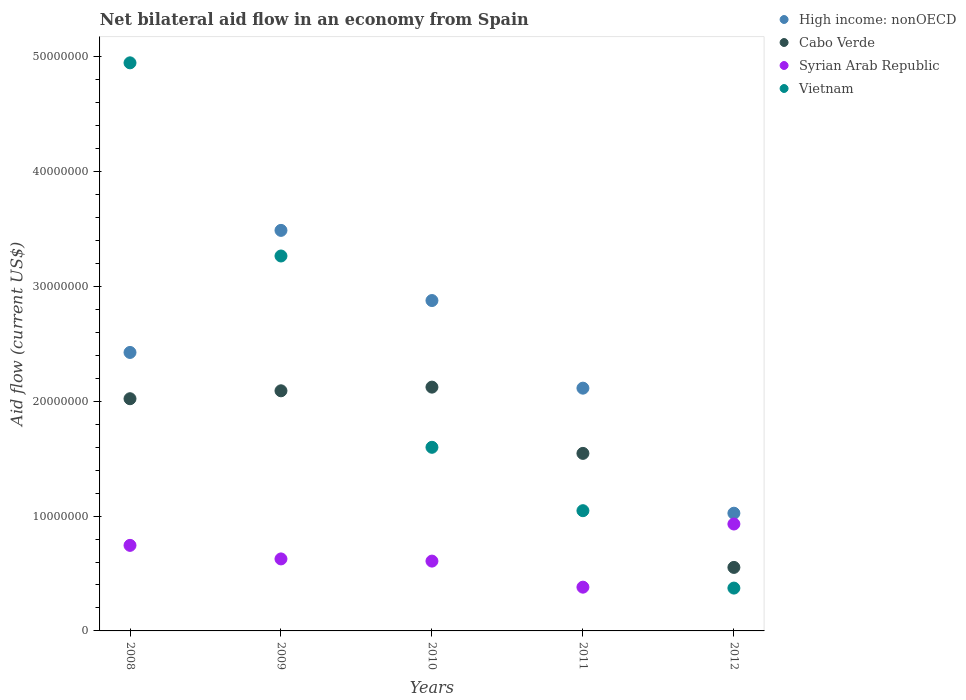How many different coloured dotlines are there?
Provide a short and direct response. 4. Is the number of dotlines equal to the number of legend labels?
Keep it short and to the point. Yes. What is the net bilateral aid flow in Vietnam in 2009?
Your response must be concise. 3.26e+07. Across all years, what is the maximum net bilateral aid flow in Cabo Verde?
Offer a very short reply. 2.12e+07. Across all years, what is the minimum net bilateral aid flow in Vietnam?
Your answer should be very brief. 3.73e+06. In which year was the net bilateral aid flow in Vietnam minimum?
Provide a succinct answer. 2012. What is the total net bilateral aid flow in Cabo Verde in the graph?
Keep it short and to the point. 8.34e+07. What is the difference between the net bilateral aid flow in Syrian Arab Republic in 2008 and that in 2009?
Ensure brevity in your answer.  1.18e+06. What is the difference between the net bilateral aid flow in High income: nonOECD in 2011 and the net bilateral aid flow in Cabo Verde in 2008?
Offer a terse response. 9.20e+05. What is the average net bilateral aid flow in Syrian Arab Republic per year?
Provide a succinct answer. 6.58e+06. In the year 2010, what is the difference between the net bilateral aid flow in High income: nonOECD and net bilateral aid flow in Cabo Verde?
Your answer should be very brief. 7.54e+06. What is the ratio of the net bilateral aid flow in Cabo Verde in 2008 to that in 2012?
Your response must be concise. 3.66. Is the difference between the net bilateral aid flow in High income: nonOECD in 2010 and 2012 greater than the difference between the net bilateral aid flow in Cabo Verde in 2010 and 2012?
Keep it short and to the point. Yes. What is the difference between the highest and the second highest net bilateral aid flow in Vietnam?
Make the answer very short. 1.68e+07. What is the difference between the highest and the lowest net bilateral aid flow in High income: nonOECD?
Ensure brevity in your answer.  2.46e+07. In how many years, is the net bilateral aid flow in Cabo Verde greater than the average net bilateral aid flow in Cabo Verde taken over all years?
Offer a terse response. 3. Is the sum of the net bilateral aid flow in Syrian Arab Republic in 2009 and 2011 greater than the maximum net bilateral aid flow in Cabo Verde across all years?
Offer a terse response. No. Is it the case that in every year, the sum of the net bilateral aid flow in Syrian Arab Republic and net bilateral aid flow in High income: nonOECD  is greater than the sum of net bilateral aid flow in Vietnam and net bilateral aid flow in Cabo Verde?
Ensure brevity in your answer.  No. Is it the case that in every year, the sum of the net bilateral aid flow in Vietnam and net bilateral aid flow in Syrian Arab Republic  is greater than the net bilateral aid flow in High income: nonOECD?
Give a very brief answer. No. Is the net bilateral aid flow in Vietnam strictly greater than the net bilateral aid flow in Syrian Arab Republic over the years?
Keep it short and to the point. No. Is the net bilateral aid flow in Vietnam strictly less than the net bilateral aid flow in Syrian Arab Republic over the years?
Ensure brevity in your answer.  No. How many years are there in the graph?
Ensure brevity in your answer.  5. Are the values on the major ticks of Y-axis written in scientific E-notation?
Offer a terse response. No. How are the legend labels stacked?
Make the answer very short. Vertical. What is the title of the graph?
Offer a terse response. Net bilateral aid flow in an economy from Spain. Does "Libya" appear as one of the legend labels in the graph?
Offer a terse response. No. What is the Aid flow (current US$) in High income: nonOECD in 2008?
Your response must be concise. 2.42e+07. What is the Aid flow (current US$) in Cabo Verde in 2008?
Keep it short and to the point. 2.02e+07. What is the Aid flow (current US$) of Syrian Arab Republic in 2008?
Make the answer very short. 7.45e+06. What is the Aid flow (current US$) of Vietnam in 2008?
Offer a very short reply. 4.95e+07. What is the Aid flow (current US$) in High income: nonOECD in 2009?
Ensure brevity in your answer.  3.49e+07. What is the Aid flow (current US$) in Cabo Verde in 2009?
Provide a succinct answer. 2.09e+07. What is the Aid flow (current US$) in Syrian Arab Republic in 2009?
Provide a short and direct response. 6.27e+06. What is the Aid flow (current US$) in Vietnam in 2009?
Offer a very short reply. 3.26e+07. What is the Aid flow (current US$) in High income: nonOECD in 2010?
Your answer should be compact. 2.88e+07. What is the Aid flow (current US$) of Cabo Verde in 2010?
Provide a short and direct response. 2.12e+07. What is the Aid flow (current US$) in Syrian Arab Republic in 2010?
Offer a terse response. 6.08e+06. What is the Aid flow (current US$) in Vietnam in 2010?
Offer a terse response. 1.60e+07. What is the Aid flow (current US$) in High income: nonOECD in 2011?
Provide a succinct answer. 2.11e+07. What is the Aid flow (current US$) in Cabo Verde in 2011?
Your answer should be very brief. 1.55e+07. What is the Aid flow (current US$) of Syrian Arab Republic in 2011?
Your response must be concise. 3.81e+06. What is the Aid flow (current US$) of Vietnam in 2011?
Your answer should be compact. 1.05e+07. What is the Aid flow (current US$) of High income: nonOECD in 2012?
Make the answer very short. 1.02e+07. What is the Aid flow (current US$) in Cabo Verde in 2012?
Make the answer very short. 5.53e+06. What is the Aid flow (current US$) in Syrian Arab Republic in 2012?
Your answer should be very brief. 9.31e+06. What is the Aid flow (current US$) in Vietnam in 2012?
Offer a very short reply. 3.73e+06. Across all years, what is the maximum Aid flow (current US$) in High income: nonOECD?
Keep it short and to the point. 3.49e+07. Across all years, what is the maximum Aid flow (current US$) in Cabo Verde?
Make the answer very short. 2.12e+07. Across all years, what is the maximum Aid flow (current US$) of Syrian Arab Republic?
Your answer should be compact. 9.31e+06. Across all years, what is the maximum Aid flow (current US$) in Vietnam?
Keep it short and to the point. 4.95e+07. Across all years, what is the minimum Aid flow (current US$) in High income: nonOECD?
Ensure brevity in your answer.  1.02e+07. Across all years, what is the minimum Aid flow (current US$) of Cabo Verde?
Provide a short and direct response. 5.53e+06. Across all years, what is the minimum Aid flow (current US$) of Syrian Arab Republic?
Keep it short and to the point. 3.81e+06. Across all years, what is the minimum Aid flow (current US$) of Vietnam?
Provide a short and direct response. 3.73e+06. What is the total Aid flow (current US$) in High income: nonOECD in the graph?
Your answer should be very brief. 1.19e+08. What is the total Aid flow (current US$) of Cabo Verde in the graph?
Provide a succinct answer. 8.34e+07. What is the total Aid flow (current US$) of Syrian Arab Republic in the graph?
Provide a succinct answer. 3.29e+07. What is the total Aid flow (current US$) of Vietnam in the graph?
Your response must be concise. 1.12e+08. What is the difference between the Aid flow (current US$) of High income: nonOECD in 2008 and that in 2009?
Your answer should be compact. -1.06e+07. What is the difference between the Aid flow (current US$) of Cabo Verde in 2008 and that in 2009?
Offer a very short reply. -6.90e+05. What is the difference between the Aid flow (current US$) in Syrian Arab Republic in 2008 and that in 2009?
Offer a very short reply. 1.18e+06. What is the difference between the Aid flow (current US$) of Vietnam in 2008 and that in 2009?
Your answer should be compact. 1.68e+07. What is the difference between the Aid flow (current US$) of High income: nonOECD in 2008 and that in 2010?
Keep it short and to the point. -4.52e+06. What is the difference between the Aid flow (current US$) of Cabo Verde in 2008 and that in 2010?
Keep it short and to the point. -1.01e+06. What is the difference between the Aid flow (current US$) in Syrian Arab Republic in 2008 and that in 2010?
Keep it short and to the point. 1.37e+06. What is the difference between the Aid flow (current US$) in Vietnam in 2008 and that in 2010?
Offer a very short reply. 3.35e+07. What is the difference between the Aid flow (current US$) in High income: nonOECD in 2008 and that in 2011?
Your answer should be very brief. 3.11e+06. What is the difference between the Aid flow (current US$) of Cabo Verde in 2008 and that in 2011?
Your answer should be very brief. 4.76e+06. What is the difference between the Aid flow (current US$) in Syrian Arab Republic in 2008 and that in 2011?
Your answer should be very brief. 3.64e+06. What is the difference between the Aid flow (current US$) in Vietnam in 2008 and that in 2011?
Give a very brief answer. 3.90e+07. What is the difference between the Aid flow (current US$) of High income: nonOECD in 2008 and that in 2012?
Provide a short and direct response. 1.40e+07. What is the difference between the Aid flow (current US$) of Cabo Verde in 2008 and that in 2012?
Give a very brief answer. 1.47e+07. What is the difference between the Aid flow (current US$) in Syrian Arab Republic in 2008 and that in 2012?
Provide a succinct answer. -1.86e+06. What is the difference between the Aid flow (current US$) in Vietnam in 2008 and that in 2012?
Your answer should be compact. 4.57e+07. What is the difference between the Aid flow (current US$) of High income: nonOECD in 2009 and that in 2010?
Make the answer very short. 6.11e+06. What is the difference between the Aid flow (current US$) of Cabo Verde in 2009 and that in 2010?
Your answer should be very brief. -3.20e+05. What is the difference between the Aid flow (current US$) in Syrian Arab Republic in 2009 and that in 2010?
Your answer should be very brief. 1.90e+05. What is the difference between the Aid flow (current US$) of Vietnam in 2009 and that in 2010?
Make the answer very short. 1.67e+07. What is the difference between the Aid flow (current US$) in High income: nonOECD in 2009 and that in 2011?
Make the answer very short. 1.37e+07. What is the difference between the Aid flow (current US$) of Cabo Verde in 2009 and that in 2011?
Your answer should be compact. 5.45e+06. What is the difference between the Aid flow (current US$) of Syrian Arab Republic in 2009 and that in 2011?
Your answer should be compact. 2.46e+06. What is the difference between the Aid flow (current US$) in Vietnam in 2009 and that in 2011?
Provide a short and direct response. 2.22e+07. What is the difference between the Aid flow (current US$) of High income: nonOECD in 2009 and that in 2012?
Offer a very short reply. 2.46e+07. What is the difference between the Aid flow (current US$) of Cabo Verde in 2009 and that in 2012?
Offer a very short reply. 1.54e+07. What is the difference between the Aid flow (current US$) of Syrian Arab Republic in 2009 and that in 2012?
Offer a terse response. -3.04e+06. What is the difference between the Aid flow (current US$) of Vietnam in 2009 and that in 2012?
Offer a terse response. 2.89e+07. What is the difference between the Aid flow (current US$) in High income: nonOECD in 2010 and that in 2011?
Make the answer very short. 7.63e+06. What is the difference between the Aid flow (current US$) in Cabo Verde in 2010 and that in 2011?
Provide a succinct answer. 5.77e+06. What is the difference between the Aid flow (current US$) in Syrian Arab Republic in 2010 and that in 2011?
Provide a short and direct response. 2.27e+06. What is the difference between the Aid flow (current US$) in Vietnam in 2010 and that in 2011?
Make the answer very short. 5.52e+06. What is the difference between the Aid flow (current US$) in High income: nonOECD in 2010 and that in 2012?
Your answer should be compact. 1.85e+07. What is the difference between the Aid flow (current US$) in Cabo Verde in 2010 and that in 2012?
Your answer should be very brief. 1.57e+07. What is the difference between the Aid flow (current US$) in Syrian Arab Republic in 2010 and that in 2012?
Ensure brevity in your answer.  -3.23e+06. What is the difference between the Aid flow (current US$) in Vietnam in 2010 and that in 2012?
Offer a very short reply. 1.23e+07. What is the difference between the Aid flow (current US$) of High income: nonOECD in 2011 and that in 2012?
Provide a succinct answer. 1.09e+07. What is the difference between the Aid flow (current US$) of Cabo Verde in 2011 and that in 2012?
Ensure brevity in your answer.  9.93e+06. What is the difference between the Aid flow (current US$) of Syrian Arab Republic in 2011 and that in 2012?
Your answer should be compact. -5.50e+06. What is the difference between the Aid flow (current US$) of Vietnam in 2011 and that in 2012?
Keep it short and to the point. 6.74e+06. What is the difference between the Aid flow (current US$) in High income: nonOECD in 2008 and the Aid flow (current US$) in Cabo Verde in 2009?
Offer a terse response. 3.34e+06. What is the difference between the Aid flow (current US$) in High income: nonOECD in 2008 and the Aid flow (current US$) in Syrian Arab Republic in 2009?
Your response must be concise. 1.80e+07. What is the difference between the Aid flow (current US$) in High income: nonOECD in 2008 and the Aid flow (current US$) in Vietnam in 2009?
Provide a short and direct response. -8.40e+06. What is the difference between the Aid flow (current US$) in Cabo Verde in 2008 and the Aid flow (current US$) in Syrian Arab Republic in 2009?
Keep it short and to the point. 1.40e+07. What is the difference between the Aid flow (current US$) of Cabo Verde in 2008 and the Aid flow (current US$) of Vietnam in 2009?
Ensure brevity in your answer.  -1.24e+07. What is the difference between the Aid flow (current US$) of Syrian Arab Republic in 2008 and the Aid flow (current US$) of Vietnam in 2009?
Offer a terse response. -2.52e+07. What is the difference between the Aid flow (current US$) of High income: nonOECD in 2008 and the Aid flow (current US$) of Cabo Verde in 2010?
Provide a short and direct response. 3.02e+06. What is the difference between the Aid flow (current US$) in High income: nonOECD in 2008 and the Aid flow (current US$) in Syrian Arab Republic in 2010?
Give a very brief answer. 1.82e+07. What is the difference between the Aid flow (current US$) in High income: nonOECD in 2008 and the Aid flow (current US$) in Vietnam in 2010?
Give a very brief answer. 8.26e+06. What is the difference between the Aid flow (current US$) in Cabo Verde in 2008 and the Aid flow (current US$) in Syrian Arab Republic in 2010?
Give a very brief answer. 1.41e+07. What is the difference between the Aid flow (current US$) in Cabo Verde in 2008 and the Aid flow (current US$) in Vietnam in 2010?
Give a very brief answer. 4.23e+06. What is the difference between the Aid flow (current US$) of Syrian Arab Republic in 2008 and the Aid flow (current US$) of Vietnam in 2010?
Give a very brief answer. -8.54e+06. What is the difference between the Aid flow (current US$) in High income: nonOECD in 2008 and the Aid flow (current US$) in Cabo Verde in 2011?
Your answer should be compact. 8.79e+06. What is the difference between the Aid flow (current US$) in High income: nonOECD in 2008 and the Aid flow (current US$) in Syrian Arab Republic in 2011?
Your answer should be very brief. 2.04e+07. What is the difference between the Aid flow (current US$) in High income: nonOECD in 2008 and the Aid flow (current US$) in Vietnam in 2011?
Provide a succinct answer. 1.38e+07. What is the difference between the Aid flow (current US$) of Cabo Verde in 2008 and the Aid flow (current US$) of Syrian Arab Republic in 2011?
Make the answer very short. 1.64e+07. What is the difference between the Aid flow (current US$) in Cabo Verde in 2008 and the Aid flow (current US$) in Vietnam in 2011?
Give a very brief answer. 9.75e+06. What is the difference between the Aid flow (current US$) of Syrian Arab Republic in 2008 and the Aid flow (current US$) of Vietnam in 2011?
Provide a short and direct response. -3.02e+06. What is the difference between the Aid flow (current US$) in High income: nonOECD in 2008 and the Aid flow (current US$) in Cabo Verde in 2012?
Provide a short and direct response. 1.87e+07. What is the difference between the Aid flow (current US$) of High income: nonOECD in 2008 and the Aid flow (current US$) of Syrian Arab Republic in 2012?
Provide a short and direct response. 1.49e+07. What is the difference between the Aid flow (current US$) in High income: nonOECD in 2008 and the Aid flow (current US$) in Vietnam in 2012?
Your response must be concise. 2.05e+07. What is the difference between the Aid flow (current US$) in Cabo Verde in 2008 and the Aid flow (current US$) in Syrian Arab Republic in 2012?
Make the answer very short. 1.09e+07. What is the difference between the Aid flow (current US$) of Cabo Verde in 2008 and the Aid flow (current US$) of Vietnam in 2012?
Your answer should be very brief. 1.65e+07. What is the difference between the Aid flow (current US$) in Syrian Arab Republic in 2008 and the Aid flow (current US$) in Vietnam in 2012?
Ensure brevity in your answer.  3.72e+06. What is the difference between the Aid flow (current US$) in High income: nonOECD in 2009 and the Aid flow (current US$) in Cabo Verde in 2010?
Ensure brevity in your answer.  1.36e+07. What is the difference between the Aid flow (current US$) in High income: nonOECD in 2009 and the Aid flow (current US$) in Syrian Arab Republic in 2010?
Give a very brief answer. 2.88e+07. What is the difference between the Aid flow (current US$) of High income: nonOECD in 2009 and the Aid flow (current US$) of Vietnam in 2010?
Ensure brevity in your answer.  1.89e+07. What is the difference between the Aid flow (current US$) of Cabo Verde in 2009 and the Aid flow (current US$) of Syrian Arab Republic in 2010?
Ensure brevity in your answer.  1.48e+07. What is the difference between the Aid flow (current US$) in Cabo Verde in 2009 and the Aid flow (current US$) in Vietnam in 2010?
Offer a very short reply. 4.92e+06. What is the difference between the Aid flow (current US$) of Syrian Arab Republic in 2009 and the Aid flow (current US$) of Vietnam in 2010?
Give a very brief answer. -9.72e+06. What is the difference between the Aid flow (current US$) of High income: nonOECD in 2009 and the Aid flow (current US$) of Cabo Verde in 2011?
Give a very brief answer. 1.94e+07. What is the difference between the Aid flow (current US$) of High income: nonOECD in 2009 and the Aid flow (current US$) of Syrian Arab Republic in 2011?
Offer a terse response. 3.11e+07. What is the difference between the Aid flow (current US$) in High income: nonOECD in 2009 and the Aid flow (current US$) in Vietnam in 2011?
Offer a very short reply. 2.44e+07. What is the difference between the Aid flow (current US$) of Cabo Verde in 2009 and the Aid flow (current US$) of Syrian Arab Republic in 2011?
Your answer should be compact. 1.71e+07. What is the difference between the Aid flow (current US$) of Cabo Verde in 2009 and the Aid flow (current US$) of Vietnam in 2011?
Give a very brief answer. 1.04e+07. What is the difference between the Aid flow (current US$) of Syrian Arab Republic in 2009 and the Aid flow (current US$) of Vietnam in 2011?
Your answer should be compact. -4.20e+06. What is the difference between the Aid flow (current US$) in High income: nonOECD in 2009 and the Aid flow (current US$) in Cabo Verde in 2012?
Ensure brevity in your answer.  2.94e+07. What is the difference between the Aid flow (current US$) of High income: nonOECD in 2009 and the Aid flow (current US$) of Syrian Arab Republic in 2012?
Ensure brevity in your answer.  2.56e+07. What is the difference between the Aid flow (current US$) in High income: nonOECD in 2009 and the Aid flow (current US$) in Vietnam in 2012?
Ensure brevity in your answer.  3.12e+07. What is the difference between the Aid flow (current US$) in Cabo Verde in 2009 and the Aid flow (current US$) in Syrian Arab Republic in 2012?
Keep it short and to the point. 1.16e+07. What is the difference between the Aid flow (current US$) in Cabo Verde in 2009 and the Aid flow (current US$) in Vietnam in 2012?
Provide a short and direct response. 1.72e+07. What is the difference between the Aid flow (current US$) of Syrian Arab Republic in 2009 and the Aid flow (current US$) of Vietnam in 2012?
Your answer should be very brief. 2.54e+06. What is the difference between the Aid flow (current US$) in High income: nonOECD in 2010 and the Aid flow (current US$) in Cabo Verde in 2011?
Offer a terse response. 1.33e+07. What is the difference between the Aid flow (current US$) of High income: nonOECD in 2010 and the Aid flow (current US$) of Syrian Arab Republic in 2011?
Ensure brevity in your answer.  2.50e+07. What is the difference between the Aid flow (current US$) of High income: nonOECD in 2010 and the Aid flow (current US$) of Vietnam in 2011?
Your answer should be compact. 1.83e+07. What is the difference between the Aid flow (current US$) of Cabo Verde in 2010 and the Aid flow (current US$) of Syrian Arab Republic in 2011?
Your answer should be very brief. 1.74e+07. What is the difference between the Aid flow (current US$) in Cabo Verde in 2010 and the Aid flow (current US$) in Vietnam in 2011?
Offer a terse response. 1.08e+07. What is the difference between the Aid flow (current US$) of Syrian Arab Republic in 2010 and the Aid flow (current US$) of Vietnam in 2011?
Provide a succinct answer. -4.39e+06. What is the difference between the Aid flow (current US$) in High income: nonOECD in 2010 and the Aid flow (current US$) in Cabo Verde in 2012?
Your answer should be compact. 2.32e+07. What is the difference between the Aid flow (current US$) in High income: nonOECD in 2010 and the Aid flow (current US$) in Syrian Arab Republic in 2012?
Keep it short and to the point. 1.95e+07. What is the difference between the Aid flow (current US$) in High income: nonOECD in 2010 and the Aid flow (current US$) in Vietnam in 2012?
Keep it short and to the point. 2.50e+07. What is the difference between the Aid flow (current US$) of Cabo Verde in 2010 and the Aid flow (current US$) of Syrian Arab Republic in 2012?
Your answer should be compact. 1.19e+07. What is the difference between the Aid flow (current US$) of Cabo Verde in 2010 and the Aid flow (current US$) of Vietnam in 2012?
Offer a terse response. 1.75e+07. What is the difference between the Aid flow (current US$) in Syrian Arab Republic in 2010 and the Aid flow (current US$) in Vietnam in 2012?
Your response must be concise. 2.35e+06. What is the difference between the Aid flow (current US$) in High income: nonOECD in 2011 and the Aid flow (current US$) in Cabo Verde in 2012?
Your response must be concise. 1.56e+07. What is the difference between the Aid flow (current US$) in High income: nonOECD in 2011 and the Aid flow (current US$) in Syrian Arab Republic in 2012?
Your response must be concise. 1.18e+07. What is the difference between the Aid flow (current US$) of High income: nonOECD in 2011 and the Aid flow (current US$) of Vietnam in 2012?
Your answer should be very brief. 1.74e+07. What is the difference between the Aid flow (current US$) of Cabo Verde in 2011 and the Aid flow (current US$) of Syrian Arab Republic in 2012?
Ensure brevity in your answer.  6.15e+06. What is the difference between the Aid flow (current US$) in Cabo Verde in 2011 and the Aid flow (current US$) in Vietnam in 2012?
Offer a terse response. 1.17e+07. What is the average Aid flow (current US$) in High income: nonOECD per year?
Provide a short and direct response. 2.39e+07. What is the average Aid flow (current US$) in Cabo Verde per year?
Your response must be concise. 1.67e+07. What is the average Aid flow (current US$) of Syrian Arab Republic per year?
Make the answer very short. 6.58e+06. What is the average Aid flow (current US$) in Vietnam per year?
Give a very brief answer. 2.25e+07. In the year 2008, what is the difference between the Aid flow (current US$) in High income: nonOECD and Aid flow (current US$) in Cabo Verde?
Provide a short and direct response. 4.03e+06. In the year 2008, what is the difference between the Aid flow (current US$) of High income: nonOECD and Aid flow (current US$) of Syrian Arab Republic?
Make the answer very short. 1.68e+07. In the year 2008, what is the difference between the Aid flow (current US$) in High income: nonOECD and Aid flow (current US$) in Vietnam?
Ensure brevity in your answer.  -2.52e+07. In the year 2008, what is the difference between the Aid flow (current US$) in Cabo Verde and Aid flow (current US$) in Syrian Arab Republic?
Make the answer very short. 1.28e+07. In the year 2008, what is the difference between the Aid flow (current US$) in Cabo Verde and Aid flow (current US$) in Vietnam?
Make the answer very short. -2.92e+07. In the year 2008, what is the difference between the Aid flow (current US$) in Syrian Arab Republic and Aid flow (current US$) in Vietnam?
Make the answer very short. -4.20e+07. In the year 2009, what is the difference between the Aid flow (current US$) of High income: nonOECD and Aid flow (current US$) of Cabo Verde?
Offer a very short reply. 1.40e+07. In the year 2009, what is the difference between the Aid flow (current US$) in High income: nonOECD and Aid flow (current US$) in Syrian Arab Republic?
Your response must be concise. 2.86e+07. In the year 2009, what is the difference between the Aid flow (current US$) of High income: nonOECD and Aid flow (current US$) of Vietnam?
Offer a terse response. 2.23e+06. In the year 2009, what is the difference between the Aid flow (current US$) in Cabo Verde and Aid flow (current US$) in Syrian Arab Republic?
Keep it short and to the point. 1.46e+07. In the year 2009, what is the difference between the Aid flow (current US$) of Cabo Verde and Aid flow (current US$) of Vietnam?
Keep it short and to the point. -1.17e+07. In the year 2009, what is the difference between the Aid flow (current US$) of Syrian Arab Republic and Aid flow (current US$) of Vietnam?
Provide a short and direct response. -2.64e+07. In the year 2010, what is the difference between the Aid flow (current US$) in High income: nonOECD and Aid flow (current US$) in Cabo Verde?
Provide a short and direct response. 7.54e+06. In the year 2010, what is the difference between the Aid flow (current US$) of High income: nonOECD and Aid flow (current US$) of Syrian Arab Republic?
Make the answer very short. 2.27e+07. In the year 2010, what is the difference between the Aid flow (current US$) of High income: nonOECD and Aid flow (current US$) of Vietnam?
Offer a very short reply. 1.28e+07. In the year 2010, what is the difference between the Aid flow (current US$) in Cabo Verde and Aid flow (current US$) in Syrian Arab Republic?
Provide a short and direct response. 1.52e+07. In the year 2010, what is the difference between the Aid flow (current US$) of Cabo Verde and Aid flow (current US$) of Vietnam?
Provide a short and direct response. 5.24e+06. In the year 2010, what is the difference between the Aid flow (current US$) in Syrian Arab Republic and Aid flow (current US$) in Vietnam?
Keep it short and to the point. -9.91e+06. In the year 2011, what is the difference between the Aid flow (current US$) of High income: nonOECD and Aid flow (current US$) of Cabo Verde?
Offer a terse response. 5.68e+06. In the year 2011, what is the difference between the Aid flow (current US$) in High income: nonOECD and Aid flow (current US$) in Syrian Arab Republic?
Make the answer very short. 1.73e+07. In the year 2011, what is the difference between the Aid flow (current US$) in High income: nonOECD and Aid flow (current US$) in Vietnam?
Keep it short and to the point. 1.07e+07. In the year 2011, what is the difference between the Aid flow (current US$) of Cabo Verde and Aid flow (current US$) of Syrian Arab Republic?
Keep it short and to the point. 1.16e+07. In the year 2011, what is the difference between the Aid flow (current US$) of Cabo Verde and Aid flow (current US$) of Vietnam?
Your answer should be compact. 4.99e+06. In the year 2011, what is the difference between the Aid flow (current US$) in Syrian Arab Republic and Aid flow (current US$) in Vietnam?
Make the answer very short. -6.66e+06. In the year 2012, what is the difference between the Aid flow (current US$) in High income: nonOECD and Aid flow (current US$) in Cabo Verde?
Make the answer very short. 4.72e+06. In the year 2012, what is the difference between the Aid flow (current US$) in High income: nonOECD and Aid flow (current US$) in Syrian Arab Republic?
Offer a very short reply. 9.40e+05. In the year 2012, what is the difference between the Aid flow (current US$) of High income: nonOECD and Aid flow (current US$) of Vietnam?
Provide a succinct answer. 6.52e+06. In the year 2012, what is the difference between the Aid flow (current US$) of Cabo Verde and Aid flow (current US$) of Syrian Arab Republic?
Provide a short and direct response. -3.78e+06. In the year 2012, what is the difference between the Aid flow (current US$) of Cabo Verde and Aid flow (current US$) of Vietnam?
Provide a short and direct response. 1.80e+06. In the year 2012, what is the difference between the Aid flow (current US$) in Syrian Arab Republic and Aid flow (current US$) in Vietnam?
Offer a very short reply. 5.58e+06. What is the ratio of the Aid flow (current US$) of High income: nonOECD in 2008 to that in 2009?
Your answer should be very brief. 0.7. What is the ratio of the Aid flow (current US$) of Cabo Verde in 2008 to that in 2009?
Give a very brief answer. 0.97. What is the ratio of the Aid flow (current US$) of Syrian Arab Republic in 2008 to that in 2009?
Your answer should be compact. 1.19. What is the ratio of the Aid flow (current US$) in Vietnam in 2008 to that in 2009?
Your response must be concise. 1.52. What is the ratio of the Aid flow (current US$) of High income: nonOECD in 2008 to that in 2010?
Make the answer very short. 0.84. What is the ratio of the Aid flow (current US$) of Cabo Verde in 2008 to that in 2010?
Provide a succinct answer. 0.95. What is the ratio of the Aid flow (current US$) in Syrian Arab Republic in 2008 to that in 2010?
Make the answer very short. 1.23. What is the ratio of the Aid flow (current US$) of Vietnam in 2008 to that in 2010?
Your response must be concise. 3.09. What is the ratio of the Aid flow (current US$) in High income: nonOECD in 2008 to that in 2011?
Your answer should be compact. 1.15. What is the ratio of the Aid flow (current US$) in Cabo Verde in 2008 to that in 2011?
Your response must be concise. 1.31. What is the ratio of the Aid flow (current US$) of Syrian Arab Republic in 2008 to that in 2011?
Give a very brief answer. 1.96. What is the ratio of the Aid flow (current US$) of Vietnam in 2008 to that in 2011?
Your answer should be very brief. 4.72. What is the ratio of the Aid flow (current US$) in High income: nonOECD in 2008 to that in 2012?
Keep it short and to the point. 2.37. What is the ratio of the Aid flow (current US$) in Cabo Verde in 2008 to that in 2012?
Keep it short and to the point. 3.66. What is the ratio of the Aid flow (current US$) in Syrian Arab Republic in 2008 to that in 2012?
Offer a very short reply. 0.8. What is the ratio of the Aid flow (current US$) of Vietnam in 2008 to that in 2012?
Your response must be concise. 13.26. What is the ratio of the Aid flow (current US$) of High income: nonOECD in 2009 to that in 2010?
Offer a very short reply. 1.21. What is the ratio of the Aid flow (current US$) of Cabo Verde in 2009 to that in 2010?
Your response must be concise. 0.98. What is the ratio of the Aid flow (current US$) in Syrian Arab Republic in 2009 to that in 2010?
Offer a very short reply. 1.03. What is the ratio of the Aid flow (current US$) of Vietnam in 2009 to that in 2010?
Offer a very short reply. 2.04. What is the ratio of the Aid flow (current US$) of High income: nonOECD in 2009 to that in 2011?
Your answer should be very brief. 1.65. What is the ratio of the Aid flow (current US$) in Cabo Verde in 2009 to that in 2011?
Ensure brevity in your answer.  1.35. What is the ratio of the Aid flow (current US$) in Syrian Arab Republic in 2009 to that in 2011?
Offer a terse response. 1.65. What is the ratio of the Aid flow (current US$) of Vietnam in 2009 to that in 2011?
Provide a succinct answer. 3.12. What is the ratio of the Aid flow (current US$) in High income: nonOECD in 2009 to that in 2012?
Your answer should be very brief. 3.4. What is the ratio of the Aid flow (current US$) of Cabo Verde in 2009 to that in 2012?
Offer a very short reply. 3.78. What is the ratio of the Aid flow (current US$) in Syrian Arab Republic in 2009 to that in 2012?
Your response must be concise. 0.67. What is the ratio of the Aid flow (current US$) of Vietnam in 2009 to that in 2012?
Keep it short and to the point. 8.75. What is the ratio of the Aid flow (current US$) in High income: nonOECD in 2010 to that in 2011?
Make the answer very short. 1.36. What is the ratio of the Aid flow (current US$) in Cabo Verde in 2010 to that in 2011?
Offer a terse response. 1.37. What is the ratio of the Aid flow (current US$) in Syrian Arab Republic in 2010 to that in 2011?
Give a very brief answer. 1.6. What is the ratio of the Aid flow (current US$) in Vietnam in 2010 to that in 2011?
Make the answer very short. 1.53. What is the ratio of the Aid flow (current US$) in High income: nonOECD in 2010 to that in 2012?
Offer a terse response. 2.81. What is the ratio of the Aid flow (current US$) of Cabo Verde in 2010 to that in 2012?
Your answer should be very brief. 3.84. What is the ratio of the Aid flow (current US$) of Syrian Arab Republic in 2010 to that in 2012?
Offer a very short reply. 0.65. What is the ratio of the Aid flow (current US$) of Vietnam in 2010 to that in 2012?
Give a very brief answer. 4.29. What is the ratio of the Aid flow (current US$) in High income: nonOECD in 2011 to that in 2012?
Make the answer very short. 2.06. What is the ratio of the Aid flow (current US$) of Cabo Verde in 2011 to that in 2012?
Your answer should be very brief. 2.8. What is the ratio of the Aid flow (current US$) of Syrian Arab Republic in 2011 to that in 2012?
Ensure brevity in your answer.  0.41. What is the ratio of the Aid flow (current US$) in Vietnam in 2011 to that in 2012?
Your answer should be very brief. 2.81. What is the difference between the highest and the second highest Aid flow (current US$) of High income: nonOECD?
Provide a short and direct response. 6.11e+06. What is the difference between the highest and the second highest Aid flow (current US$) of Cabo Verde?
Provide a short and direct response. 3.20e+05. What is the difference between the highest and the second highest Aid flow (current US$) of Syrian Arab Republic?
Provide a short and direct response. 1.86e+06. What is the difference between the highest and the second highest Aid flow (current US$) in Vietnam?
Ensure brevity in your answer.  1.68e+07. What is the difference between the highest and the lowest Aid flow (current US$) of High income: nonOECD?
Give a very brief answer. 2.46e+07. What is the difference between the highest and the lowest Aid flow (current US$) in Cabo Verde?
Give a very brief answer. 1.57e+07. What is the difference between the highest and the lowest Aid flow (current US$) in Syrian Arab Republic?
Offer a terse response. 5.50e+06. What is the difference between the highest and the lowest Aid flow (current US$) in Vietnam?
Provide a succinct answer. 4.57e+07. 